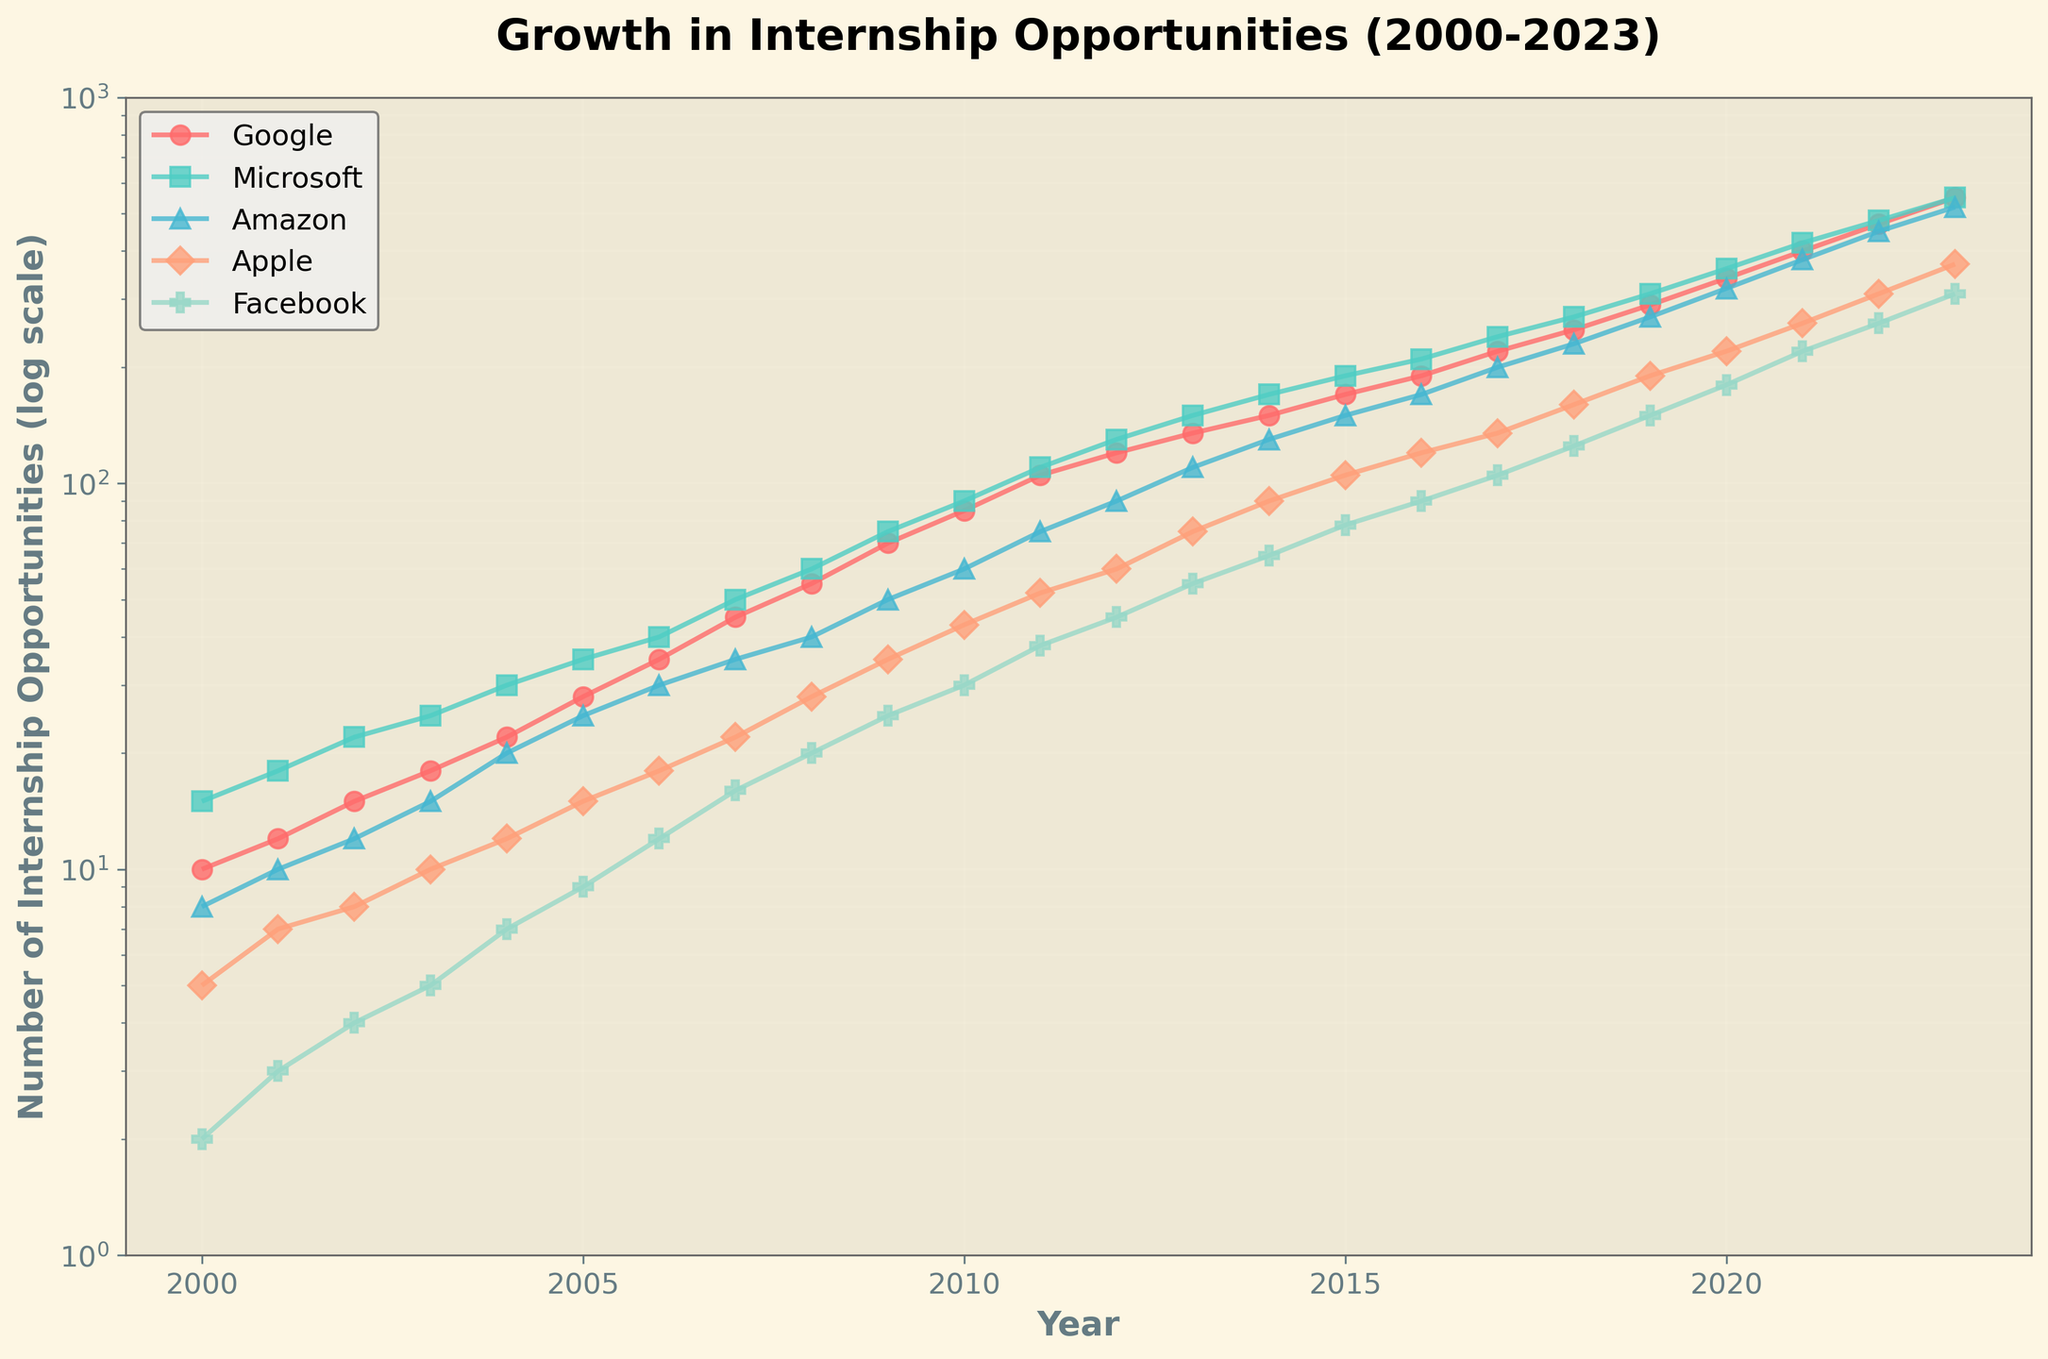How many internship opportunities did Apple offer in 2015? Check the figure for the year 2015 on the x-axis, then look at Apple's line to find the corresponding point. Read the y-value.
Answer: 105 Which company had the highest number of internship opportunities in 2023? Identify the points for 2023 on the x-axis for each company and compare the y-values. The company with the highest y-value in 2023 is the answer.
Answer: Google In which year did Facebook surpass Apple in offering the number of internship opportunities? Track both Facebook's and Apple's lines on the plot and find the first year where Facebook's point is higher than Apple's on the y-axis.
Answer: 2010 By how much did the number of Amazon's internship opportunities increase from 2000 to 2023? Find Amazon's points on the y-axis for the years 2000 and 2023, then calculate the difference between these values.
Answer: 512 What is the general trend in the number of internship opportunities offered by Microsoft between 2000 and 2023? Observe the shape and direction of the line corresponding to Microsoft from 2000 to 2023.
Answer: Increasing How many internship opportunities did Google offer in 2020, and how does it compare to the same year's offering by Amazon? Find Google's and Amazon's points for 2020 on the x-axis and compare their y-values.
Answer: Google 340, Amazon 320 What is the approximate annual growth rate of Facebook's internship opportunities from 2000 to 2023? Calculate the increase in Facebook's opportunities from 2000 to 2023, and divide by the number of years (23) to approximate the annual growth rate.
Answer: 13 Which year saw the highest increase in internship opportunities for Microsoft compared to the previous year? Compute the differences between consecutive y-values for Microsoft for each year and identify the year with the largest increase.
Answer: 2004 On the log scale, which company's growth in internship opportunities appears to be the most exponential over the period shown? Examine the steepness and curvature of each company's line on the plot; the line that appears to rise most sharply in an exponential pattern corresponds to the answer.
Answer: Facebook 